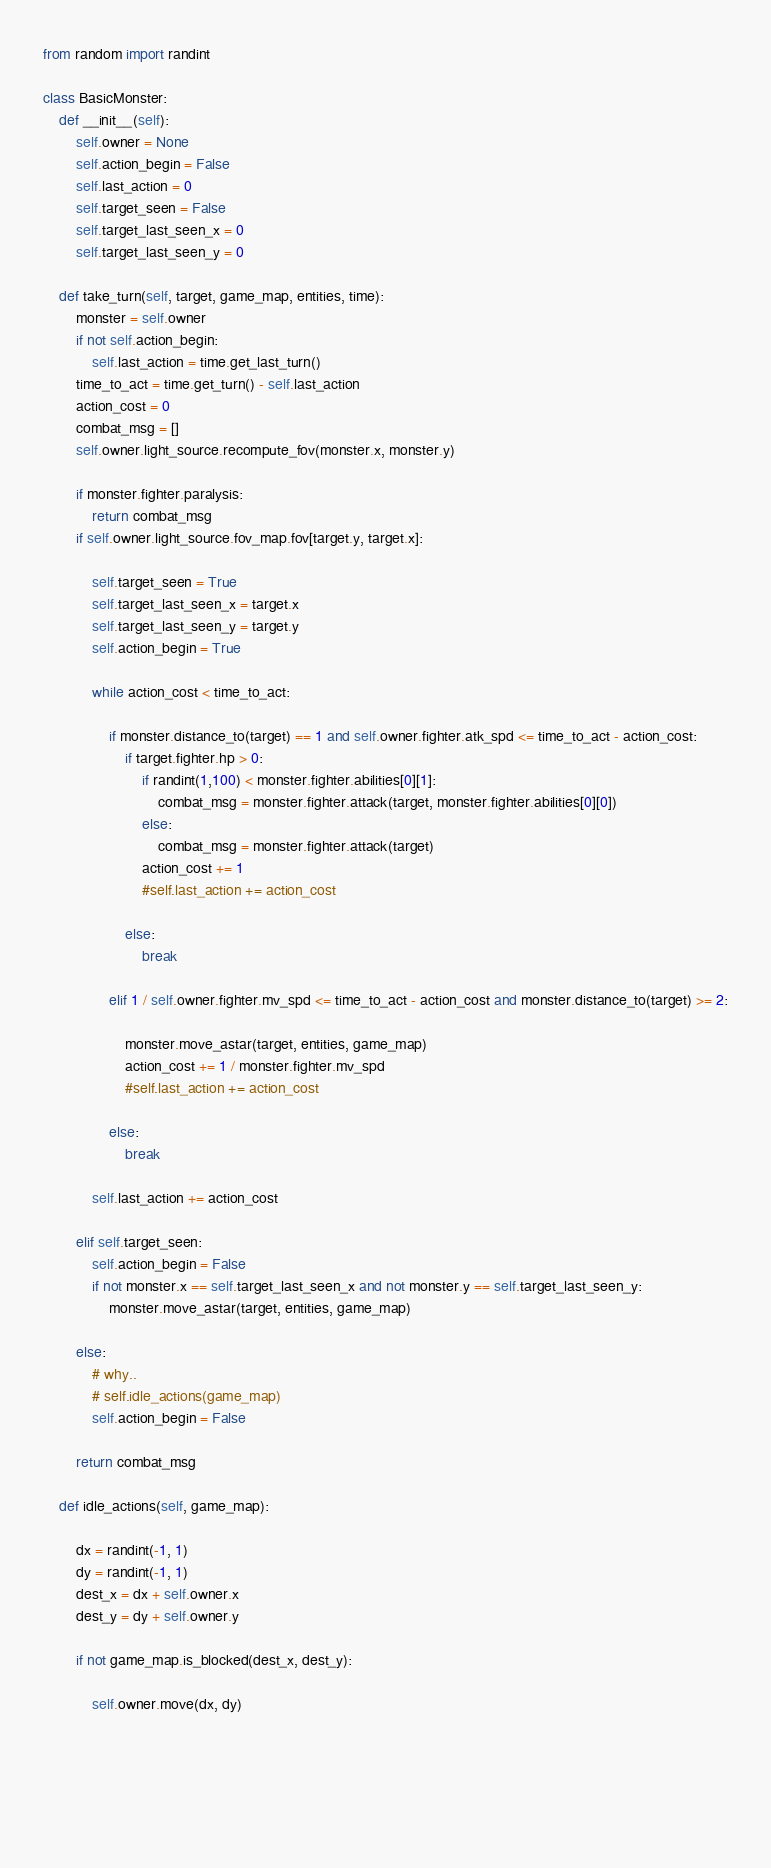<code> <loc_0><loc_0><loc_500><loc_500><_Python_>from random import randint

class BasicMonster:
    def __init__(self):
        self.owner = None
        self.action_begin = False
        self.last_action = 0
        self.target_seen = False
        self.target_last_seen_x = 0
        self.target_last_seen_y = 0

    def take_turn(self, target, game_map, entities, time):
        monster = self.owner
        if not self.action_begin:
            self.last_action = time.get_last_turn()
        time_to_act = time.get_turn() - self.last_action
        action_cost = 0
        combat_msg = []
        self.owner.light_source.recompute_fov(monster.x, monster.y)
        
        if monster.fighter.paralysis:
            return combat_msg
        if self.owner.light_source.fov_map.fov[target.y, target.x]:
            
            self.target_seen = True
            self.target_last_seen_x = target.x
            self.target_last_seen_y = target.y
            self.action_begin = True
            
            while action_cost < time_to_act: 

                if monster.distance_to(target) == 1 and self.owner.fighter.atk_spd <= time_to_act - action_cost: 
                    if target.fighter.hp > 0:
                        if randint(1,100) < monster.fighter.abilities[0][1]:
                            combat_msg = monster.fighter.attack(target, monster.fighter.abilities[0][0])
                        else:
                            combat_msg = monster.fighter.attack(target)
                        action_cost += 1
                        #self.last_action += action_cost

                    else:
                        break
                    
                elif 1 / self.owner.fighter.mv_spd <= time_to_act - action_cost and monster.distance_to(target) >= 2:

                    monster.move_astar(target, entities, game_map)
                    action_cost += 1 / monster.fighter.mv_spd
                    #self.last_action += action_cost
                        
                else:
                    break

            self.last_action += action_cost

        elif self.target_seen:
            self.action_begin = False
            if not monster.x == self.target_last_seen_x and not monster.y == self.target_last_seen_y:
                monster.move_astar(target, entities, game_map)
            
        else:
            # why..
            # self.idle_actions(game_map)
            self.action_begin = False

        return combat_msg
    
    def idle_actions(self, game_map):
        
        dx = randint(-1, 1)
        dy = randint(-1, 1)
        dest_x = dx + self.owner.x
        dest_y = dy + self.owner.y
        
        if not game_map.is_blocked(dest_x, dest_y):
            
            self.owner.move(dx, dy)

            

        
    </code> 